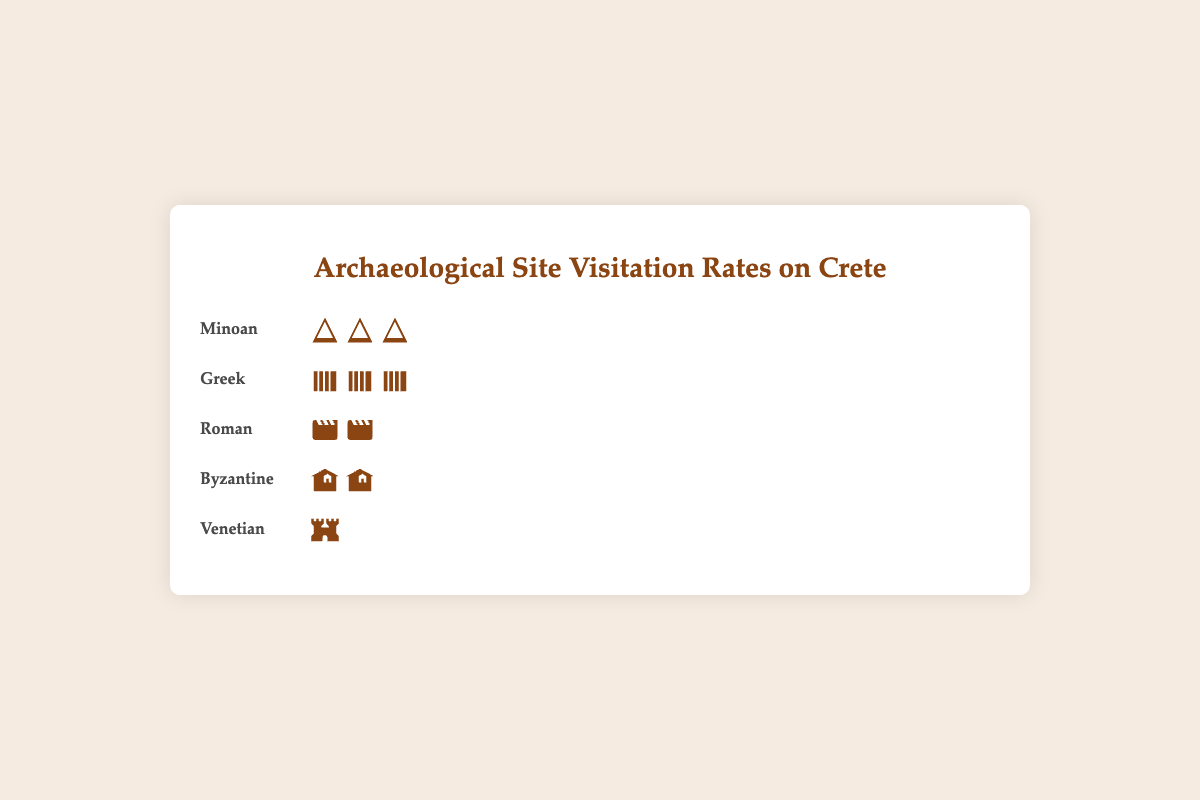What's the most visited historical period according to the plot? The figure shows the periods and the number of icons representing the visitation rates. Counting the icons, the Minoan period has three "ancient ruins" icons, the most among all periods.
Answer: Minoan Which period has the least visitors? The Venitian period shows only one "fortress" icon, representing the least visitors among the periods shown.
Answer: Venetian How many more visitors per 1000 does the Greek period have compared to the Byzantine period? The Greek period has 25 visitors per 1000, while the Byzantine period has 15 visitors per 1000. The difference is calculated as 25 - 15.
Answer: 10 What is the total number of visitors per 1000 for the Roman and Byzantine periods combined? The Roman period shows 20 visitors per 1000 and the Byzantine period shows 15 visitors per 1000. The total is 20 + 15.
Answer: 35 What's the relationship between the number of icons and visitors per 1000? Each icon represents 10 visitors per 1000. This can be observed by considering that the Minoan period has 30 visitors per 1000 and has three "ancient ruins" icons.
Answer: Each icon represents 10 visitors per 1000 Which period has just half the visitors of the Minoan period? The Minoan period has 30 visitors per 1000. Half of this is 15 visitors per 1000, which is the visitation rate of the Byzantine period, represented by two "church" icons.
Answer: Byzantine If you rank the periods from most visited to least visited, what is the correct order? Counting the icons: Minoan (3), Greek (2.5), Roman (2), Byzantine (1.5), Venetian (1).
Answer: Minoan, Greek, Roman, Byzantine, Venetian How many icons in total are used to represent the data in the figure? Adding up all icons: Minoan (3) + Greek (2.5) + Roman (2) + Byzantine (1.5) + Venetian (1). Note: We'd round the Greek and Byzantine icons to whole numbers in visualization practice, but here giving the literal icon counts.
Answer: 10.5 Which two periods have exactly one less icon in total than the Minoan period? The Byzantine period (1.5 icons) and the Venetian period (1 icon) together sum up to 1.5 + 1 = 2.5 icons, which is one less than the Minoan period's 3 icons.
Answer: Byzantine and Venetian 